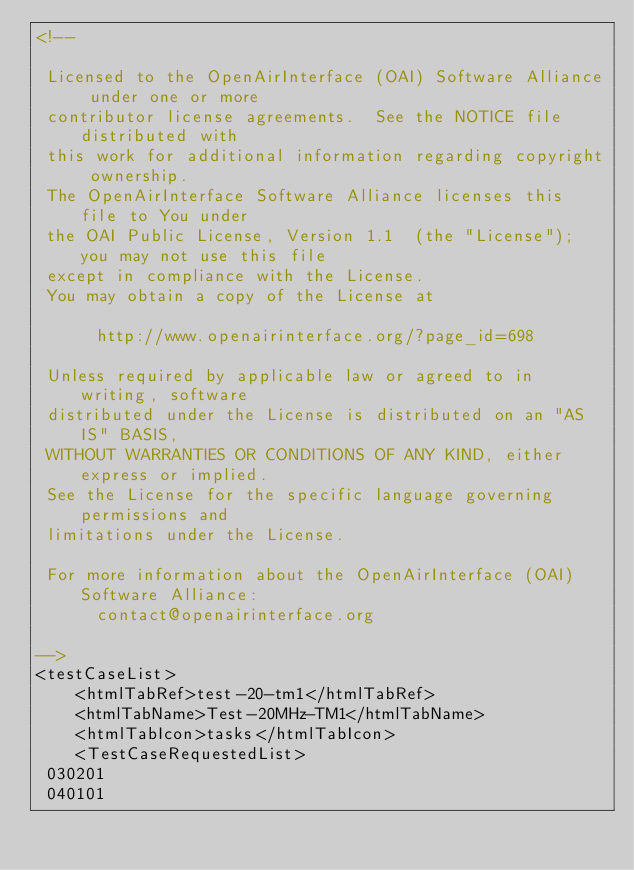<code> <loc_0><loc_0><loc_500><loc_500><_XML_><!--

 Licensed to the OpenAirInterface (OAI) Software Alliance under one or more
 contributor license agreements.  See the NOTICE file distributed with
 this work for additional information regarding copyright ownership.
 The OpenAirInterface Software Alliance licenses this file to You under
 the OAI Public License, Version 1.1  (the "License"); you may not use this file
 except in compliance with the License.
 You may obtain a copy of the License at

      http://www.openairinterface.org/?page_id=698

 Unless required by applicable law or agreed to in writing, software
 distributed under the License is distributed on an "AS IS" BASIS,
 WITHOUT WARRANTIES OR CONDITIONS OF ANY KIND, either express or implied.
 See the License for the specific language governing permissions and
 limitations under the License.

 For more information about the OpenAirInterface (OAI) Software Alliance:
      contact@openairinterface.org

-->
<testCaseList>
	<htmlTabRef>test-20-tm1</htmlTabRef>
	<htmlTabName>Test-20MHz-TM1</htmlTabName>
	<htmlTabIcon>tasks</htmlTabIcon>
	<TestCaseRequestedList>
 030201
 040101</code> 